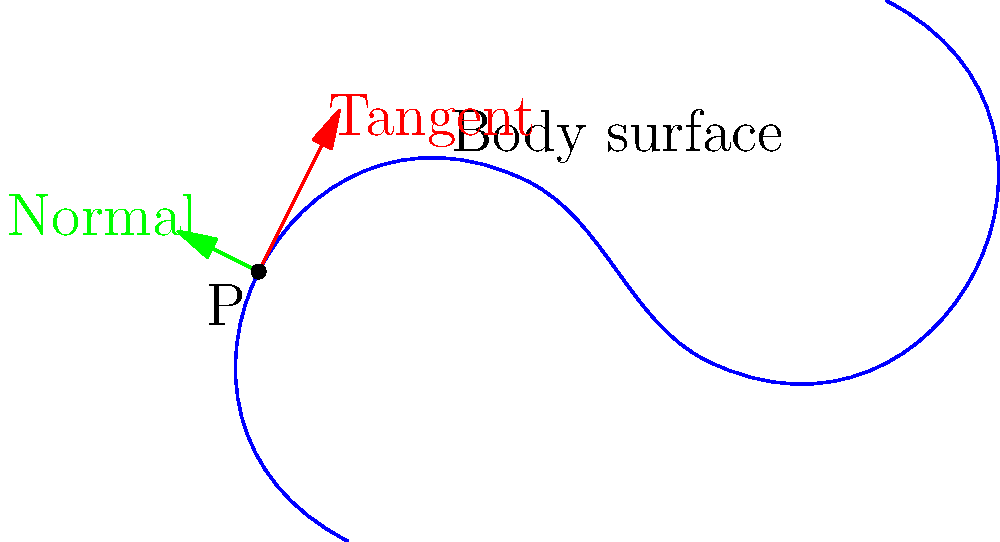As a body painter, you're working on a project that requires precise calculations of body curvature. Consider the curve representing a body surface shown in the diagram. At point P, the tangent line (red) and normal vector (green) are illustrated. If the parametric equations of the curve are $x(t) = t$ and $y(t) = 2t^2 - t^3$, calculate the curvature $\kappa$ at point P, where $t = 0.5$. To calculate the curvature at point P, we'll follow these steps:

1) The formula for curvature is:

   $$\kappa = \frac{|x'y'' - y'x''|}{(x'^2 + y'^2)^{3/2}}$$

2) Calculate the first derivatives:
   $x'(t) = 1$
   $y'(t) = 4t - 3t^2$

3) Calculate the second derivatives:
   $x''(t) = 0$
   $y''(t) = 4 - 6t$

4) Evaluate the derivatives at $t = 0.5$:
   $x'(0.5) = 1$
   $y'(0.5) = 4(0.5) - 3(0.5)^2 = 2 - 0.75 = 1.25$
   $x''(0.5) = 0$
   $y''(0.5) = 4 - 6(0.5) = 1$

5) Substitute into the curvature formula:

   $$\kappa = \frac{|1(1) - 1.25(0)|}{(1^2 + 1.25^2)^{3/2}}$$

6) Simplify:
   $$\kappa = \frac{1}{(1 + 1.5625)^{3/2}} = \frac{1}{2.5625^{3/2}}$$

7) Calculate the final result:
   $$\kappa \approx 0.2462$$
Answer: $\kappa \approx 0.2462$ 